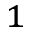Convert formula to latex. <formula><loc_0><loc_0><loc_500><loc_500>^ { 1 }</formula> 